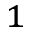Convert formula to latex. <formula><loc_0><loc_0><loc_500><loc_500>^ { 1 }</formula> 